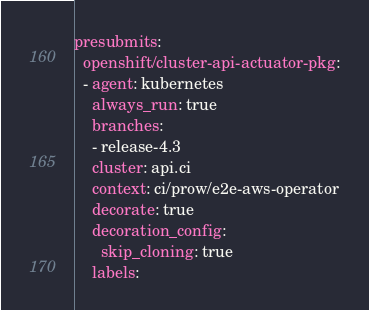Convert code to text. <code><loc_0><loc_0><loc_500><loc_500><_YAML_>presubmits:
  openshift/cluster-api-actuator-pkg:
  - agent: kubernetes
    always_run: true
    branches:
    - release-4.3
    cluster: api.ci
    context: ci/prow/e2e-aws-operator
    decorate: true
    decoration_config:
      skip_cloning: true
    labels:</code> 